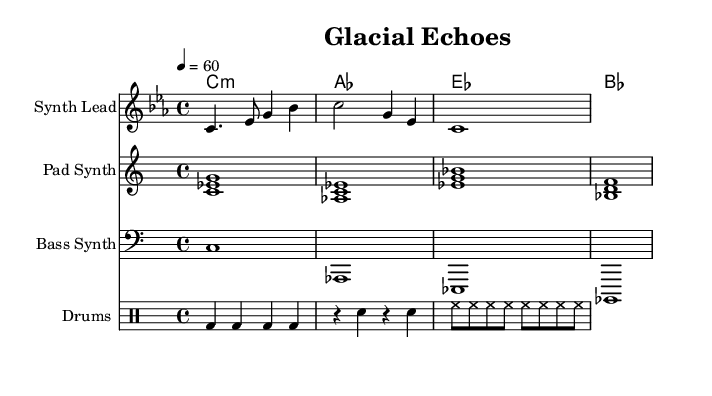What is the key signature of this music? The key signature is C minor, which has three flats (B♭, E♭, A♭). The key is indicated at the beginning of the score.
Answer: C minor What is the time signature of this music? The time signature is 4/4, which means there are four beats in each measure and the quarter note gets one beat. This is stated at the beginning of the score.
Answer: 4/4 What is the tempo indicated in this music? The tempo is indicated as 60 beats per minute, as denoted by the "4 = 60" marking at the beginning. This specifies the speed at which the piece should be played.
Answer: 60 How many measures are in the melody? The melody contains four measures, as it is structured in four distinct groupings of notes separated by bar lines. Counting the segments provides the total.
Answer: 4 What type of instrument is specified for the lead melody? The lead melody is specified for a "Synth Lead," indicating that a synthesizer should be used for this part. This is noted in the instrument name at the beginning of the respective staff.
Answer: Synth Lead What other synths are specified in this composition? There are two other synths specified: "Pad Synth" for the pad and "Bass Synth" for the bass. This is shown by the names written above their respective staffs within the score.
Answer: Pad Synth and Bass Synth What percussion instruments are indicated in this piece? The percussion part is identified as "Drums," and consists of bass drum, snare, and hi-hat. This is indicated at the top of the drum staff.
Answer: Drums 